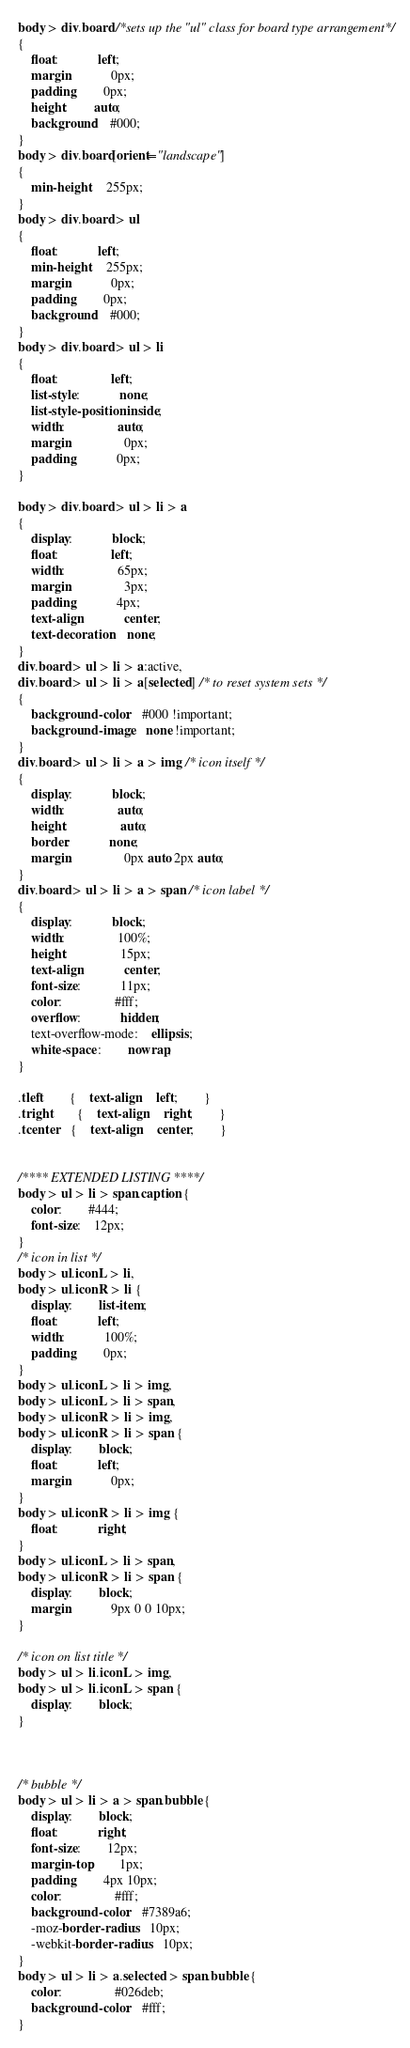<code> <loc_0><loc_0><loc_500><loc_500><_CSS_>body > div.board /*sets up the "ul" class for board type arrangement*/
{
	float:			left;
	margin:			0px;
	padding: 		0px;
    height: 		auto;
   	background: 	#000;
}
body > div.board[orient="landscape"]
{
    min-height: 	255px;
}
body > div.board > ul
{
	float:			left;
    min-height: 	255px;
	margin:			0px;
	padding:		0px;
	background: 	#000;
}
body > div.board > ul > li
{
	float:				left;
	list-style:			none;
	list-style-position:inside;
	width: 				auto;
	margin:				0px;
	padding:			0px;
}

body > div.board > ul > li > a
{
	display:			block;
	float:				left;
	width:				65px;
	margin:				3px;
	padding:			4px;
	text-align:			center;
	text-decoration:	none;
}
div.board > ul > li > a:active,
div.board > ul > li > a[selected] /* to reset system sets */
{
    background-color: 	#000 !important;
    background-image: 	none !important;
}
div.board > ul > li > a > img /* icon itself */
{
	display:			block;
	width:				auto;
	height:				auto;
	border: 			none;
	margin:				0px auto 2px auto;
}
div.board > ul > li > a > span /* icon label */
{
	display:			block;
	width: 				100%;
	height:				15px;
	text-align:			center;
	font-size:			11px;
	color:				#fff;
	overflow:			hidden;
	text-overflow-mode:	ellipsis;
	white-space : 		nowrap;
}

.tleft		{	text-align:	left;		}
.tright		{	text-align:	right;		}
.tcenter	{	text-align:	center;		}


/**** EXTENDED LISTING ****/
body > ul > li > span.caption {
	color:		#444;
	font-size:	12px;
}
/* icon in list */ 
body > ul.iconL > li,
body > ul.iconR > li {
	display:		list-item;
	float:			left;
	width:			100%;
	padding:		0px;
}
body > ul.iconL > li > img,
body > ul.iconL > li > span,
body > ul.iconR > li > img,
body > ul.iconR > li > span {
	display:		block;
	float:			left;
	margin:			0px;
}
body > ul.iconR > li > img {
	float:			right;
}
body > ul.iconL > li > span,
body > ul.iconR > li > span {
	display:		block;
	margin:			9px 0 0 10px;
}

/* icon on list title */
body > ul > li.iconL > img,
body > ul > li.iconL > span {
	display:		block;
}



/* bubble */
body > ul > li > a > span.bubble {
	display:		block;
	float:			right;
	font-size:		12px;
	margin-top:		1px;
	padding:		4px 10px;
	color:				#fff;
	background-color:	#7389a6;
	-moz-border-radius: 	10px;
	-webkit-border-radius: 	10px;
}
body > ul > li > a.selected > span.bubble {
	color:				#026deb;
	background-color:	#fff;
}</code> 